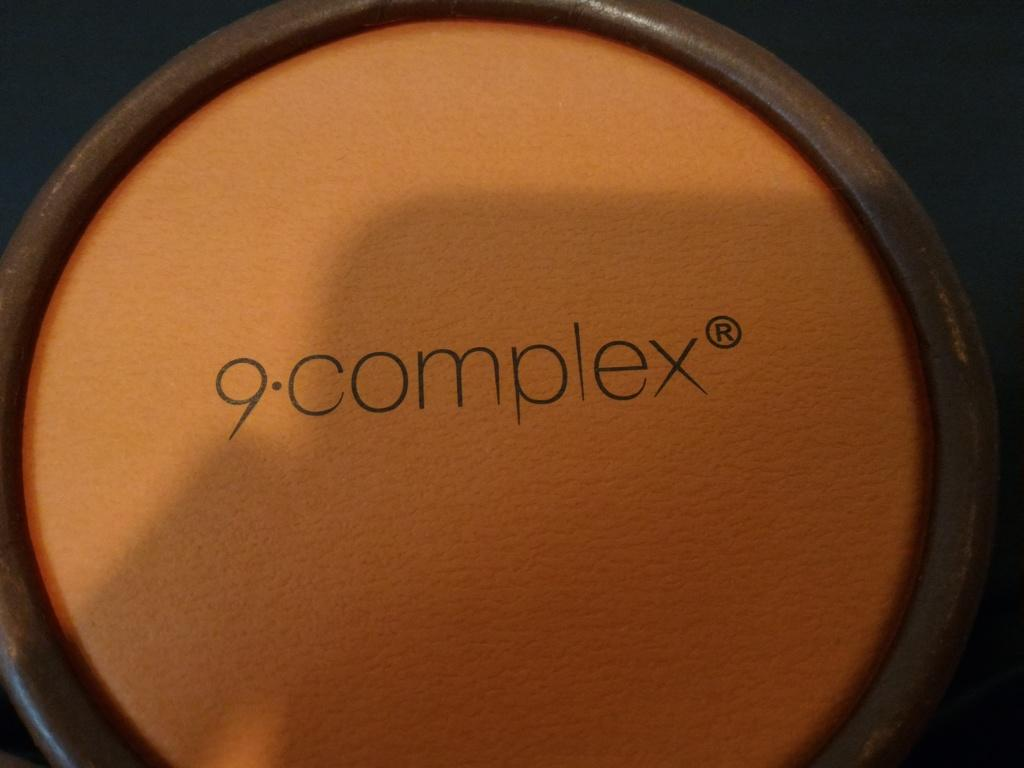What substance is present in the image? There is a powder in the image. Where is the powder located? The powder is in a container. What type of seed is being planted by the actor in the image? There is no actor or seed present in the image; it only features a powder in a container. 